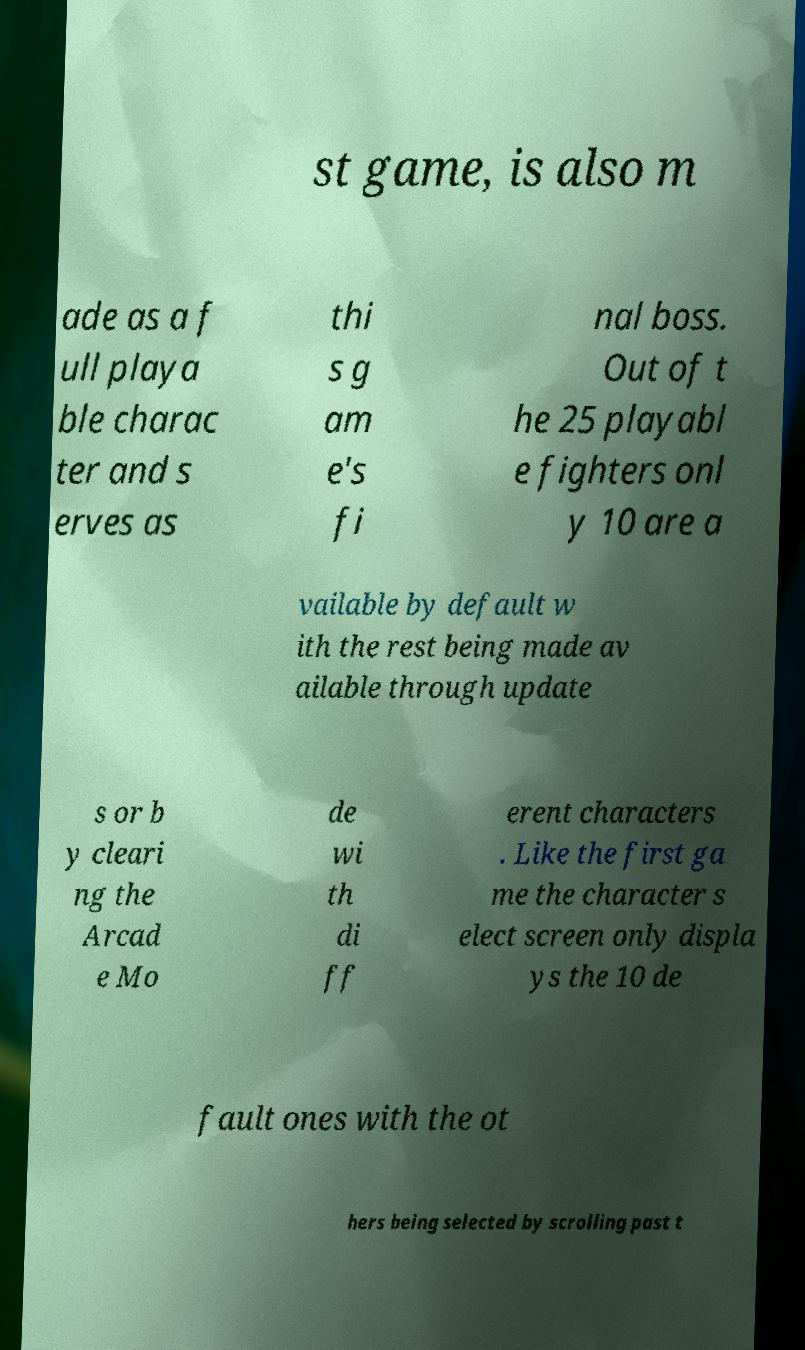Please identify and transcribe the text found in this image. st game, is also m ade as a f ull playa ble charac ter and s erves as thi s g am e's fi nal boss. Out of t he 25 playabl e fighters onl y 10 are a vailable by default w ith the rest being made av ailable through update s or b y cleari ng the Arcad e Mo de wi th di ff erent characters . Like the first ga me the character s elect screen only displa ys the 10 de fault ones with the ot hers being selected by scrolling past t 